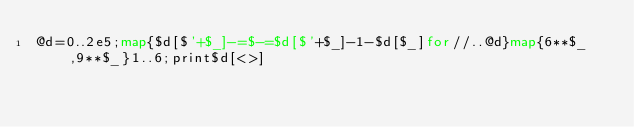<code> <loc_0><loc_0><loc_500><loc_500><_Perl_>@d=0..2e5;map{$d[$'+$_]-=$-=$d[$'+$_]-1-$d[$_]for//..@d}map{6**$_,9**$_}1..6;print$d[<>]</code> 